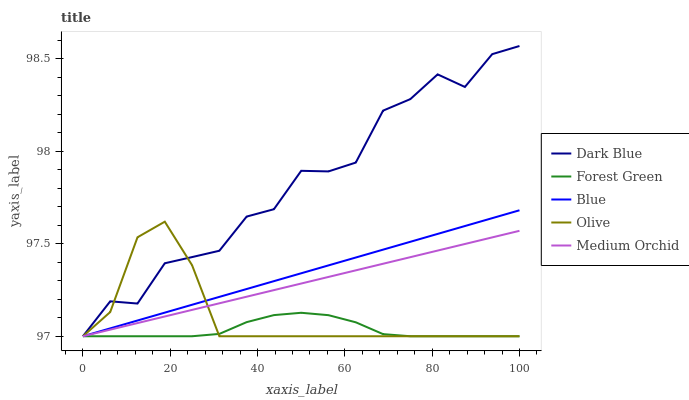Does Forest Green have the minimum area under the curve?
Answer yes or no. Yes. Does Dark Blue have the maximum area under the curve?
Answer yes or no. Yes. Does Dark Blue have the minimum area under the curve?
Answer yes or no. No. Does Forest Green have the maximum area under the curve?
Answer yes or no. No. Is Blue the smoothest?
Answer yes or no. Yes. Is Dark Blue the roughest?
Answer yes or no. Yes. Is Forest Green the smoothest?
Answer yes or no. No. Is Forest Green the roughest?
Answer yes or no. No. Does Blue have the lowest value?
Answer yes or no. Yes. Does Dark Blue have the highest value?
Answer yes or no. Yes. Does Forest Green have the highest value?
Answer yes or no. No. Does Forest Green intersect Blue?
Answer yes or no. Yes. Is Forest Green less than Blue?
Answer yes or no. No. Is Forest Green greater than Blue?
Answer yes or no. No. 